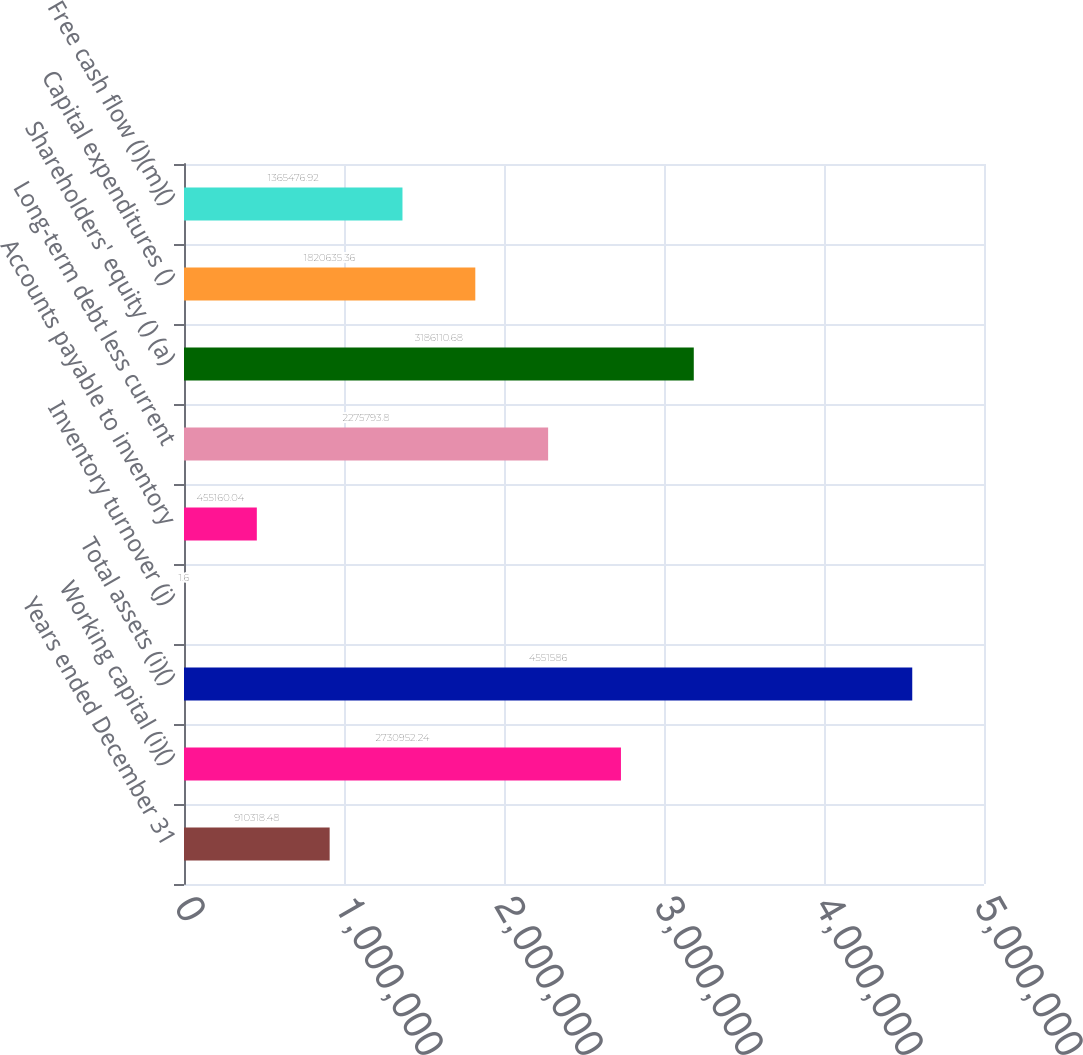Convert chart. <chart><loc_0><loc_0><loc_500><loc_500><bar_chart><fcel>Years ended December 31<fcel>Working capital (i)()<fcel>Total assets (i)()<fcel>Inventory turnover (j)<fcel>Accounts payable to inventory<fcel>Long-term debt less current<fcel>Shareholders' equity () (a)<fcel>Capital expenditures ()<fcel>Free cash flow (l)(m)()<nl><fcel>910318<fcel>2.73095e+06<fcel>4.55159e+06<fcel>1.6<fcel>455160<fcel>2.27579e+06<fcel>3.18611e+06<fcel>1.82064e+06<fcel>1.36548e+06<nl></chart> 